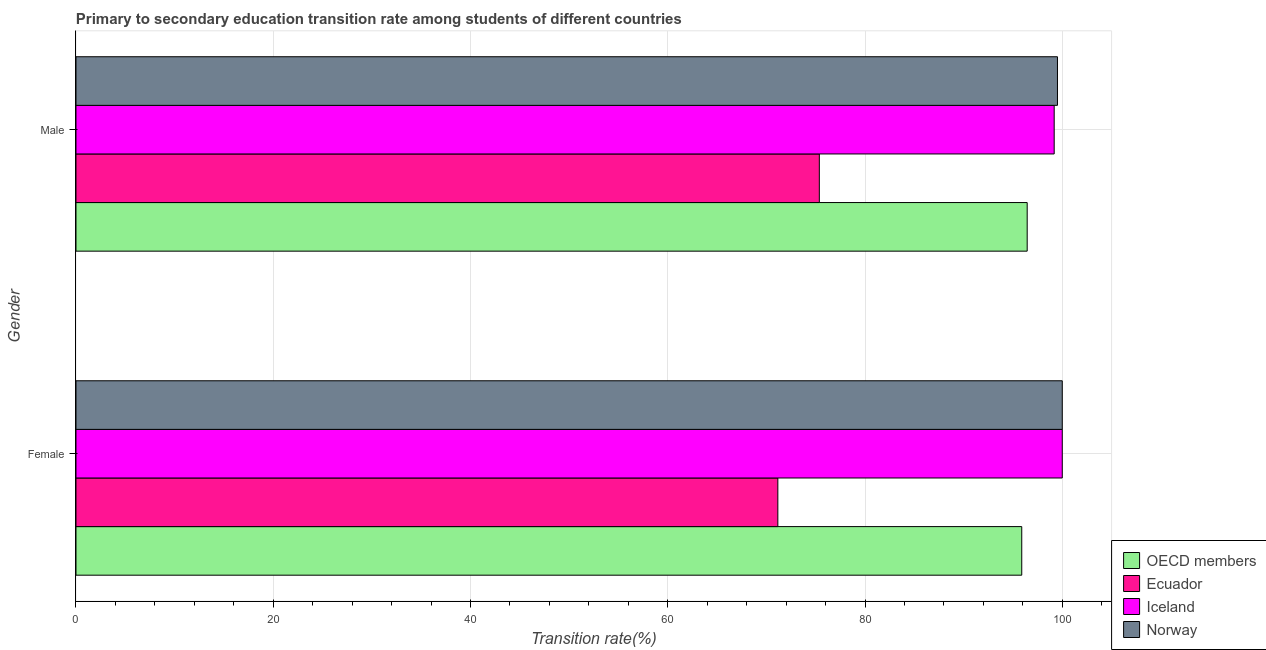How many groups of bars are there?
Your answer should be very brief. 2. Are the number of bars on each tick of the Y-axis equal?
Your answer should be compact. Yes. What is the label of the 2nd group of bars from the top?
Provide a short and direct response. Female. What is the transition rate among male students in Iceland?
Offer a terse response. 99.18. Across all countries, what is the minimum transition rate among female students?
Ensure brevity in your answer.  71.16. In which country was the transition rate among female students maximum?
Make the answer very short. Iceland. In which country was the transition rate among female students minimum?
Offer a very short reply. Ecuador. What is the total transition rate among male students in the graph?
Keep it short and to the point. 370.5. What is the difference between the transition rate among female students in OECD members and that in Iceland?
Your answer should be compact. -4.11. What is the difference between the transition rate among male students in Norway and the transition rate among female students in Iceland?
Keep it short and to the point. -0.49. What is the average transition rate among female students per country?
Offer a very short reply. 91.76. What is the difference between the transition rate among female students and transition rate among male students in Norway?
Give a very brief answer. 0.49. What is the ratio of the transition rate among female students in OECD members to that in Ecuador?
Provide a succinct answer. 1.35. Is the transition rate among female students in Ecuador less than that in Norway?
Offer a terse response. Yes. In how many countries, is the transition rate among female students greater than the average transition rate among female students taken over all countries?
Keep it short and to the point. 3. What does the 3rd bar from the top in Male represents?
Your response must be concise. Ecuador. What does the 2nd bar from the bottom in Male represents?
Offer a terse response. Ecuador. How many bars are there?
Ensure brevity in your answer.  8. Are the values on the major ticks of X-axis written in scientific E-notation?
Your response must be concise. No. Where does the legend appear in the graph?
Make the answer very short. Bottom right. How many legend labels are there?
Ensure brevity in your answer.  4. How are the legend labels stacked?
Your answer should be very brief. Vertical. What is the title of the graph?
Give a very brief answer. Primary to secondary education transition rate among students of different countries. What is the label or title of the X-axis?
Give a very brief answer. Transition rate(%). What is the Transition rate(%) of OECD members in Female?
Offer a terse response. 95.89. What is the Transition rate(%) of Ecuador in Female?
Provide a succinct answer. 71.16. What is the Transition rate(%) in OECD members in Male?
Make the answer very short. 96.44. What is the Transition rate(%) of Ecuador in Male?
Make the answer very short. 75.37. What is the Transition rate(%) of Iceland in Male?
Your response must be concise. 99.18. What is the Transition rate(%) in Norway in Male?
Offer a very short reply. 99.51. Across all Gender, what is the maximum Transition rate(%) in OECD members?
Your response must be concise. 96.44. Across all Gender, what is the maximum Transition rate(%) in Ecuador?
Your response must be concise. 75.37. Across all Gender, what is the maximum Transition rate(%) of Norway?
Offer a very short reply. 100. Across all Gender, what is the minimum Transition rate(%) in OECD members?
Provide a short and direct response. 95.89. Across all Gender, what is the minimum Transition rate(%) in Ecuador?
Give a very brief answer. 71.16. Across all Gender, what is the minimum Transition rate(%) of Iceland?
Keep it short and to the point. 99.18. Across all Gender, what is the minimum Transition rate(%) in Norway?
Provide a succinct answer. 99.51. What is the total Transition rate(%) in OECD members in the graph?
Offer a terse response. 192.33. What is the total Transition rate(%) of Ecuador in the graph?
Give a very brief answer. 146.53. What is the total Transition rate(%) in Iceland in the graph?
Keep it short and to the point. 199.18. What is the total Transition rate(%) of Norway in the graph?
Ensure brevity in your answer.  199.51. What is the difference between the Transition rate(%) of OECD members in Female and that in Male?
Give a very brief answer. -0.55. What is the difference between the Transition rate(%) in Ecuador in Female and that in Male?
Make the answer very short. -4.21. What is the difference between the Transition rate(%) of Iceland in Female and that in Male?
Your response must be concise. 0.82. What is the difference between the Transition rate(%) of Norway in Female and that in Male?
Offer a very short reply. 0.49. What is the difference between the Transition rate(%) in OECD members in Female and the Transition rate(%) in Ecuador in Male?
Give a very brief answer. 20.52. What is the difference between the Transition rate(%) of OECD members in Female and the Transition rate(%) of Iceland in Male?
Your answer should be compact. -3.29. What is the difference between the Transition rate(%) of OECD members in Female and the Transition rate(%) of Norway in Male?
Your response must be concise. -3.62. What is the difference between the Transition rate(%) in Ecuador in Female and the Transition rate(%) in Iceland in Male?
Provide a succinct answer. -28.02. What is the difference between the Transition rate(%) of Ecuador in Female and the Transition rate(%) of Norway in Male?
Keep it short and to the point. -28.35. What is the difference between the Transition rate(%) in Iceland in Female and the Transition rate(%) in Norway in Male?
Make the answer very short. 0.49. What is the average Transition rate(%) of OECD members per Gender?
Ensure brevity in your answer.  96.17. What is the average Transition rate(%) in Ecuador per Gender?
Your answer should be very brief. 73.26. What is the average Transition rate(%) in Iceland per Gender?
Give a very brief answer. 99.59. What is the average Transition rate(%) in Norway per Gender?
Keep it short and to the point. 99.76. What is the difference between the Transition rate(%) of OECD members and Transition rate(%) of Ecuador in Female?
Provide a succinct answer. 24.73. What is the difference between the Transition rate(%) in OECD members and Transition rate(%) in Iceland in Female?
Your response must be concise. -4.11. What is the difference between the Transition rate(%) in OECD members and Transition rate(%) in Norway in Female?
Your response must be concise. -4.11. What is the difference between the Transition rate(%) in Ecuador and Transition rate(%) in Iceland in Female?
Keep it short and to the point. -28.84. What is the difference between the Transition rate(%) of Ecuador and Transition rate(%) of Norway in Female?
Keep it short and to the point. -28.84. What is the difference between the Transition rate(%) in OECD members and Transition rate(%) in Ecuador in Male?
Offer a very short reply. 21.07. What is the difference between the Transition rate(%) in OECD members and Transition rate(%) in Iceland in Male?
Make the answer very short. -2.74. What is the difference between the Transition rate(%) of OECD members and Transition rate(%) of Norway in Male?
Your answer should be very brief. -3.07. What is the difference between the Transition rate(%) of Ecuador and Transition rate(%) of Iceland in Male?
Give a very brief answer. -23.81. What is the difference between the Transition rate(%) in Ecuador and Transition rate(%) in Norway in Male?
Your answer should be compact. -24.14. What is the difference between the Transition rate(%) of Iceland and Transition rate(%) of Norway in Male?
Give a very brief answer. -0.33. What is the ratio of the Transition rate(%) of OECD members in Female to that in Male?
Give a very brief answer. 0.99. What is the ratio of the Transition rate(%) of Ecuador in Female to that in Male?
Ensure brevity in your answer.  0.94. What is the ratio of the Transition rate(%) of Iceland in Female to that in Male?
Your answer should be very brief. 1.01. What is the difference between the highest and the second highest Transition rate(%) in OECD members?
Keep it short and to the point. 0.55. What is the difference between the highest and the second highest Transition rate(%) of Ecuador?
Make the answer very short. 4.21. What is the difference between the highest and the second highest Transition rate(%) of Iceland?
Offer a very short reply. 0.82. What is the difference between the highest and the second highest Transition rate(%) of Norway?
Offer a very short reply. 0.49. What is the difference between the highest and the lowest Transition rate(%) in OECD members?
Your response must be concise. 0.55. What is the difference between the highest and the lowest Transition rate(%) of Ecuador?
Your answer should be very brief. 4.21. What is the difference between the highest and the lowest Transition rate(%) of Iceland?
Keep it short and to the point. 0.82. What is the difference between the highest and the lowest Transition rate(%) of Norway?
Your answer should be compact. 0.49. 